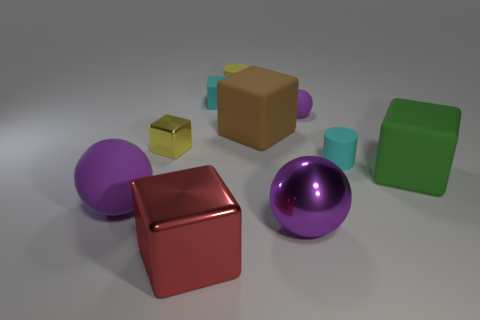There is a small cyan object that is to the left of the tiny purple object; what is its shape?
Offer a very short reply. Cube. Are there any other things that are the same shape as the small metallic thing?
Give a very brief answer. Yes. Are any rubber cylinders visible?
Your response must be concise. Yes. Does the sphere on the left side of the large red block have the same size as the cyan thing to the right of the big purple shiny ball?
Your answer should be compact. No. The object that is behind the purple metal sphere and in front of the big green matte block is made of what material?
Make the answer very short. Rubber. What number of large blocks are behind the big red metal thing?
Keep it short and to the point. 2. Is there anything else that is the same size as the brown thing?
Your response must be concise. Yes. There is a large ball that is made of the same material as the small ball; what color is it?
Offer a very short reply. Purple. Do the big red object and the large purple metallic object have the same shape?
Your response must be concise. No. How many small yellow objects are behind the big brown rubber object and on the left side of the small yellow cylinder?
Offer a terse response. 0. 